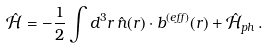Convert formula to latex. <formula><loc_0><loc_0><loc_500><loc_500>\hat { \mathcal { H } } = - \frac { 1 } { 2 } \int d ^ { 3 } r \, \hat { n } ( { r } ) \cdot { b } ^ { ( e f f ) } ( { r } ) + \hat { \mathcal { H } } _ { p h } \, .</formula> 